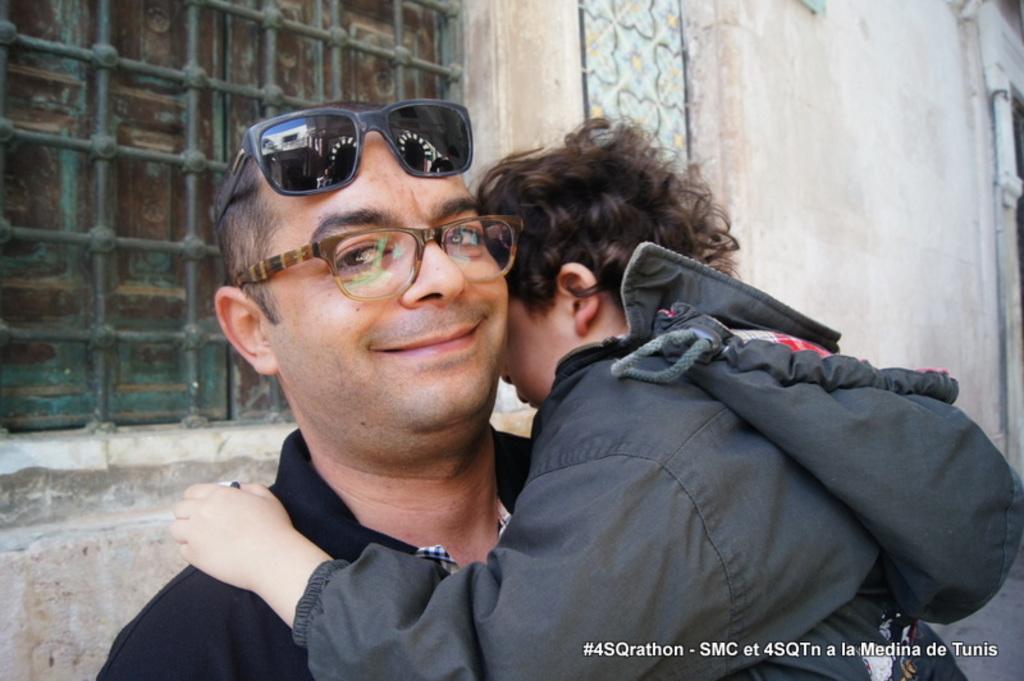Describe this image in one or two sentences. In this image I can see two people with black and grey color dress. I can see one person wearing the specs and the goggles. In the background I can see the window to the wall. 